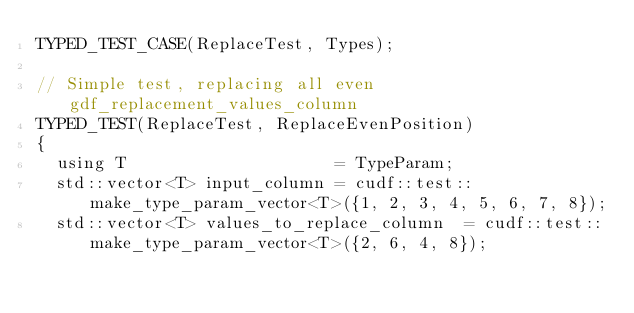<code> <loc_0><loc_0><loc_500><loc_500><_Cuda_>TYPED_TEST_CASE(ReplaceTest, Types);

// Simple test, replacing all even gdf_replacement_values_column
TYPED_TEST(ReplaceTest, ReplaceEvenPosition)
{
  using T                     = TypeParam;
  std::vector<T> input_column = cudf::test::make_type_param_vector<T>({1, 2, 3, 4, 5, 6, 7, 8});
  std::vector<T> values_to_replace_column  = cudf::test::make_type_param_vector<T>({2, 6, 4, 8});</code> 